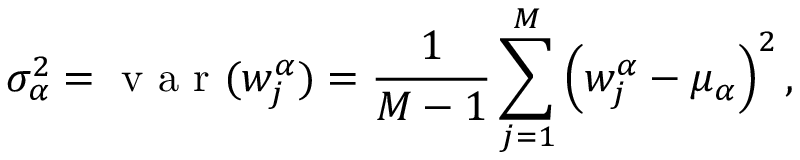Convert formula to latex. <formula><loc_0><loc_0><loc_500><loc_500>\sigma _ { \alpha } ^ { 2 } = v a r ( w _ { j } ^ { \alpha } ) = \frac { 1 } { M - 1 } \sum _ { j = 1 } ^ { M } \left ( w _ { j } ^ { \alpha } - \mu _ { \alpha } \right ) ^ { 2 } ,</formula> 